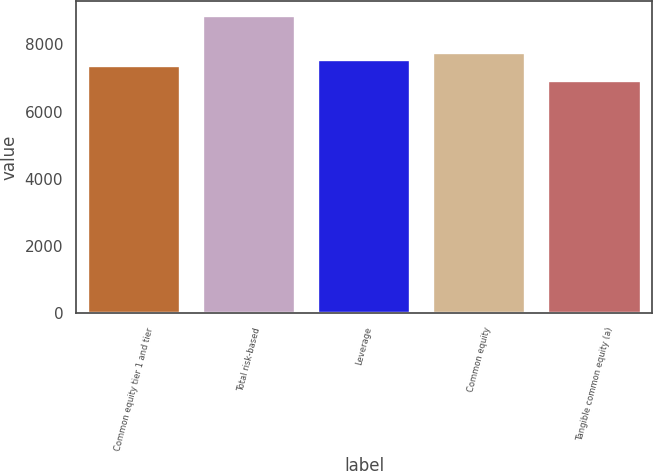<chart> <loc_0><loc_0><loc_500><loc_500><bar_chart><fcel>Common equity tier 1 and tier<fcel>Total risk-based<fcel>Leverage<fcel>Common equity<fcel>Tangible common equity (a)<nl><fcel>7350<fcel>8852<fcel>7544.1<fcel>7738.2<fcel>6911<nl></chart> 